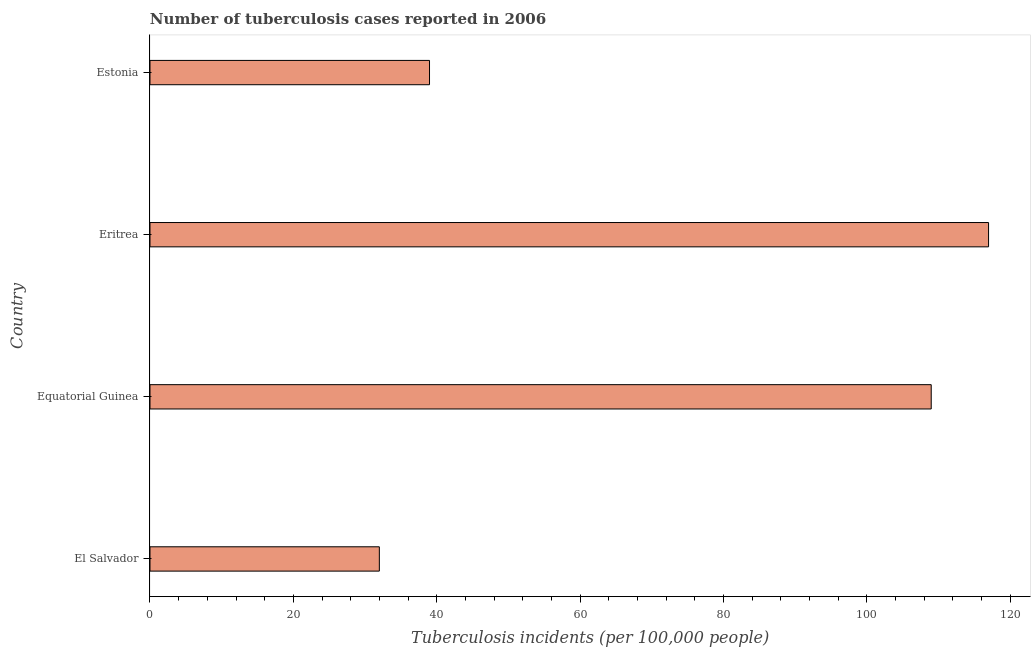What is the title of the graph?
Provide a short and direct response. Number of tuberculosis cases reported in 2006. What is the label or title of the X-axis?
Your answer should be very brief. Tuberculosis incidents (per 100,0 people). What is the number of tuberculosis incidents in Eritrea?
Provide a short and direct response. 117. Across all countries, what is the maximum number of tuberculosis incidents?
Keep it short and to the point. 117. Across all countries, what is the minimum number of tuberculosis incidents?
Make the answer very short. 32. In which country was the number of tuberculosis incidents maximum?
Your answer should be compact. Eritrea. In which country was the number of tuberculosis incidents minimum?
Make the answer very short. El Salvador. What is the sum of the number of tuberculosis incidents?
Offer a very short reply. 297. What is the average number of tuberculosis incidents per country?
Provide a short and direct response. 74.25. What is the median number of tuberculosis incidents?
Your answer should be compact. 74. What is the ratio of the number of tuberculosis incidents in El Salvador to that in Equatorial Guinea?
Your answer should be very brief. 0.29. Is the difference between the number of tuberculosis incidents in Equatorial Guinea and Eritrea greater than the difference between any two countries?
Your response must be concise. No. What is the difference between the highest and the lowest number of tuberculosis incidents?
Offer a terse response. 85. In how many countries, is the number of tuberculosis incidents greater than the average number of tuberculosis incidents taken over all countries?
Your response must be concise. 2. Are all the bars in the graph horizontal?
Your answer should be very brief. Yes. Are the values on the major ticks of X-axis written in scientific E-notation?
Your response must be concise. No. What is the Tuberculosis incidents (per 100,000 people) of Equatorial Guinea?
Your response must be concise. 109. What is the Tuberculosis incidents (per 100,000 people) of Eritrea?
Offer a very short reply. 117. What is the Tuberculosis incidents (per 100,000 people) in Estonia?
Make the answer very short. 39. What is the difference between the Tuberculosis incidents (per 100,000 people) in El Salvador and Equatorial Guinea?
Offer a very short reply. -77. What is the difference between the Tuberculosis incidents (per 100,000 people) in El Salvador and Eritrea?
Keep it short and to the point. -85. What is the ratio of the Tuberculosis incidents (per 100,000 people) in El Salvador to that in Equatorial Guinea?
Offer a very short reply. 0.29. What is the ratio of the Tuberculosis incidents (per 100,000 people) in El Salvador to that in Eritrea?
Provide a succinct answer. 0.27. What is the ratio of the Tuberculosis incidents (per 100,000 people) in El Salvador to that in Estonia?
Your response must be concise. 0.82. What is the ratio of the Tuberculosis incidents (per 100,000 people) in Equatorial Guinea to that in Eritrea?
Offer a terse response. 0.93. What is the ratio of the Tuberculosis incidents (per 100,000 people) in Equatorial Guinea to that in Estonia?
Keep it short and to the point. 2.79. 